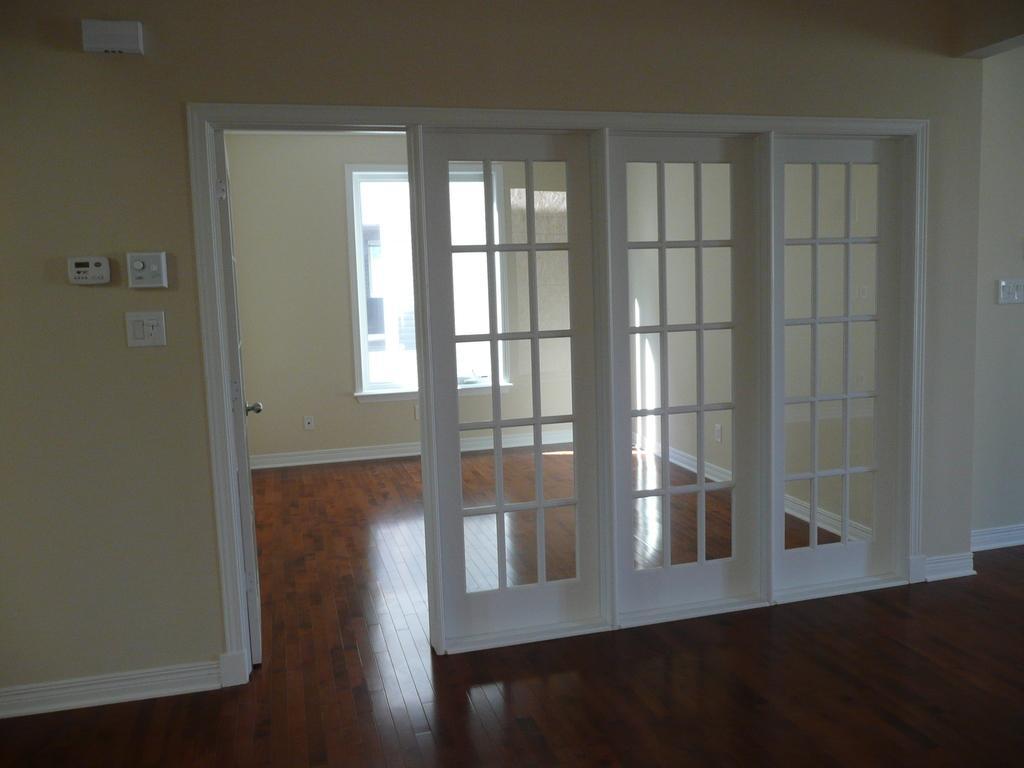Can you describe this image briefly? In this image we can see switch board, door, windows and floor. 